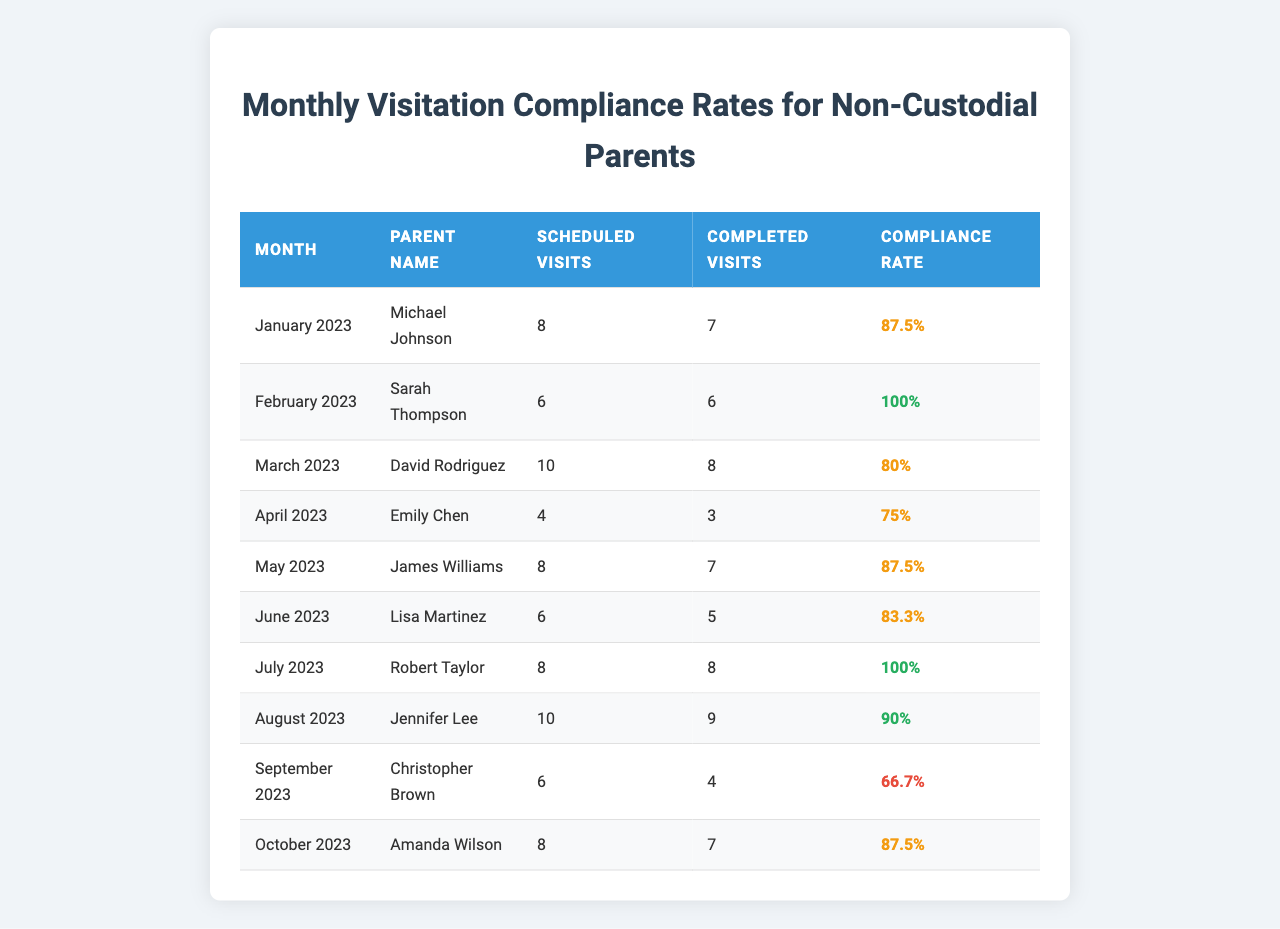What is the compliance rate for Sarah Thompson in February 2023? The table shows that Sarah Thompson has a compliance rate of 100% for February 2023.
Answer: 100% How many scheduled visits did David Rodriguez have in March 2023? According to the table, David Rodriguez had 10 scheduled visits in March 2023.
Answer: 10 Which parent had the lowest compliance rate? Christopher Brown had the lowest compliance rate of 66.7% in September 2023.
Answer: Christopher Brown What is the average compliance rate for the months of January to May 2023? To find the average, add the compliance rates: (87.5 + 100 + 80 + 75 + 87.5) = 430, then divide by 5, which equals 86.
Answer: 86 Did Robert Taylor complete all his scheduled visits in July 2023? Yes, Robert Taylor completed all 8 scheduled visits in July 2023.
Answer: Yes What was the change in compliance rate for Emily Chen from April to June 2023? Emily Chen had a compliance rate of 75% in April and 83.3% in June. The change is 83.3 - 75 = 8.3%.
Answer: 8.3% How many total completed visits were there across all parents for October 2023 and September 2023? For October 2023, there were 7 completed visits for Amanda Wilson, and for September 2023, there were 4 completed visits for Christopher Brown. Adding these gives 7 + 4 = 11 completed visits total.
Answer: 11 What percentage of scheduled visits were completed by Lisa Martinez in June 2023? Lisa Martinez completed 5 out of 6 scheduled visits. To find the percentage, divide 5 by 6 and multiply by 100, resulting in approximately 83.3%.
Answer: 83.3% Which months had a compliance rate above 90%? From the table, the months with a compliance rate above 90% are February 2023 (100%) and July 2023 (100%).
Answer: February and July What is the total number of scheduled visits among all parents for the year? The total number of scheduled visits is: 8 + 6 + 10 + 4 + 8 + 6 + 8 + 10 + 6 + 8 = 78.
Answer: 78 Is there a parent who consistently maintained a compliance rate of 100%? Yes, Sarah Thompson in February 2023 and Robert Taylor in July 2023 each maintained a compliance rate of 100%.
Answer: Yes 